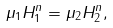Convert formula to latex. <formula><loc_0><loc_0><loc_500><loc_500>\mu _ { 1 } H _ { 1 } ^ { n } = \mu _ { 2 } H _ { 2 } ^ { n } ,</formula> 